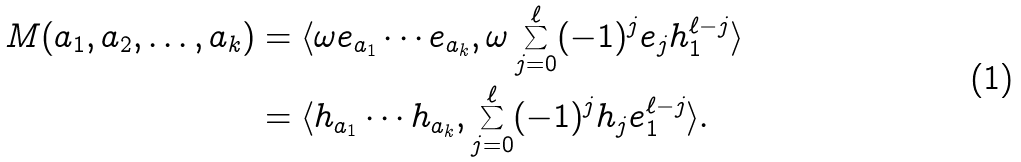<formula> <loc_0><loc_0><loc_500><loc_500>M ( a _ { 1 } , a _ { 2 } , \dots , a _ { k } ) & = \langle \omega e _ { a _ { 1 } } \cdots e _ { a _ { k } } , \omega \sum _ { j = 0 } ^ { \ell } ( - 1 ) ^ { j } e _ { j } h _ { 1 } ^ { \ell - j } \rangle \\ & = \langle h _ { a _ { 1 } } \cdots h _ { a _ { k } } , \sum _ { j = 0 } ^ { \ell } ( - 1 ) ^ { j } h _ { j } e _ { 1 } ^ { \ell - j } \rangle .</formula> 